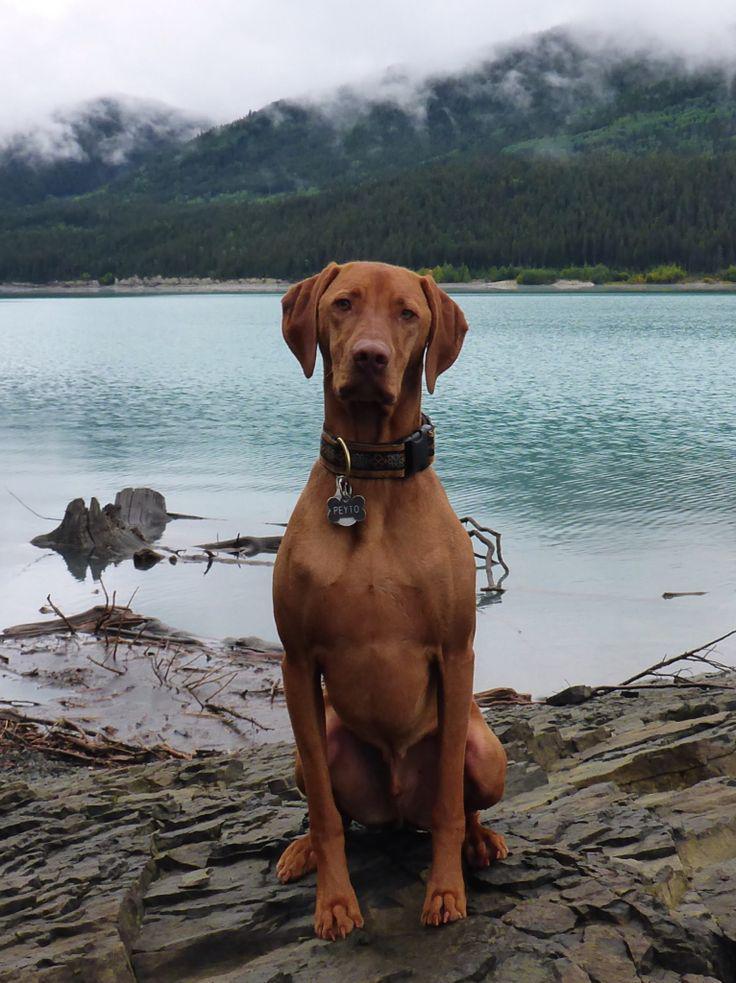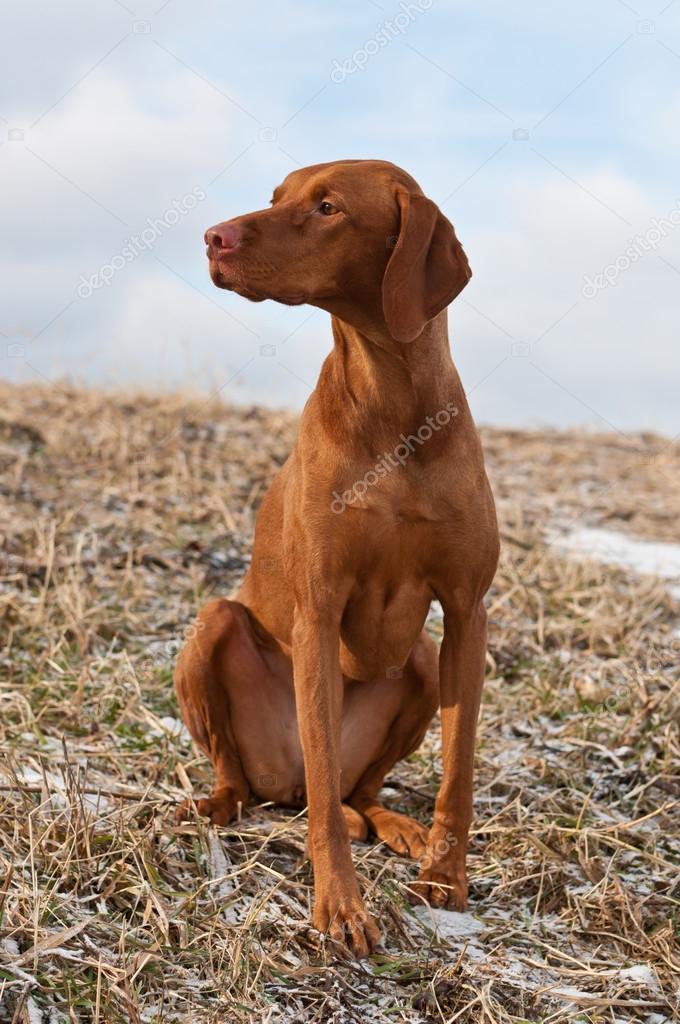The first image is the image on the left, the second image is the image on the right. Evaluate the accuracy of this statement regarding the images: "One red-orange dog is splashing through the water in one image, and the other image features at least one red-orange dog on a surface above the water.". Is it true? Answer yes or no. No. The first image is the image on the left, the second image is the image on the right. Examine the images to the left and right. Is the description "The left image contains at least two dogs." accurate? Answer yes or no. No. 